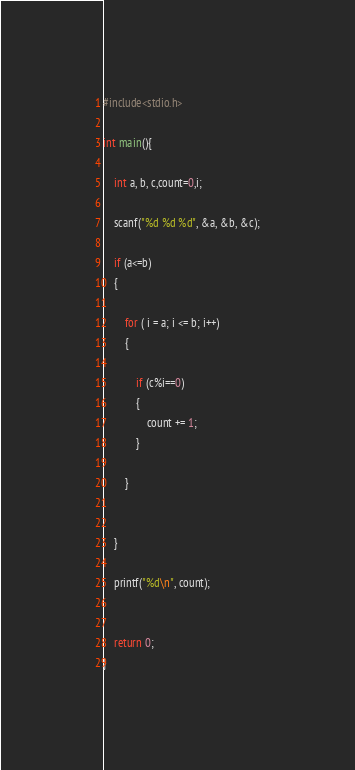Convert code to text. <code><loc_0><loc_0><loc_500><loc_500><_C_>#include<stdio.h>

int main(){

	int a, b, c,count=0,i;

	scanf("%d %d %d", &a, &b, &c);

	if (a<=b)
	{

		for ( i = a; i <= b; i++)
		{

			if (c%i==0)
			{
				count += 1;
			}

		}


	}

	printf("%d\n", count);


	return 0;
}</code> 